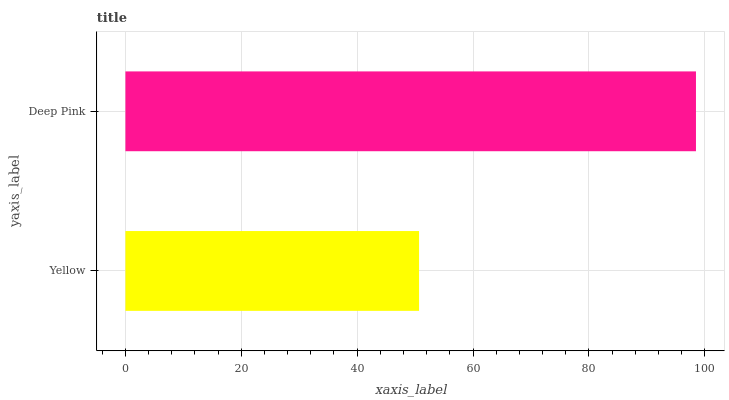Is Yellow the minimum?
Answer yes or no. Yes. Is Deep Pink the maximum?
Answer yes or no. Yes. Is Deep Pink the minimum?
Answer yes or no. No. Is Deep Pink greater than Yellow?
Answer yes or no. Yes. Is Yellow less than Deep Pink?
Answer yes or no. Yes. Is Yellow greater than Deep Pink?
Answer yes or no. No. Is Deep Pink less than Yellow?
Answer yes or no. No. Is Deep Pink the high median?
Answer yes or no. Yes. Is Yellow the low median?
Answer yes or no. Yes. Is Yellow the high median?
Answer yes or no. No. Is Deep Pink the low median?
Answer yes or no. No. 